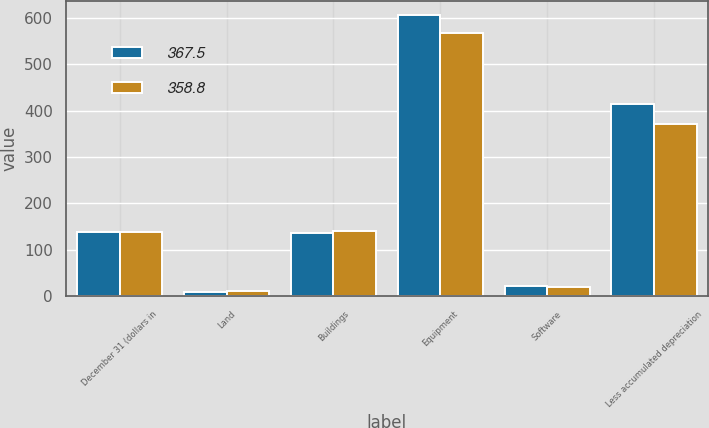<chart> <loc_0><loc_0><loc_500><loc_500><stacked_bar_chart><ecel><fcel>December 31 (dollars in<fcel>Land<fcel>Buildings<fcel>Equipment<fcel>Software<fcel>Less accumulated depreciation<nl><fcel>367.5<fcel>138.4<fcel>9.3<fcel>136.8<fcel>606.6<fcel>21.1<fcel>415<nl><fcel>358.8<fcel>138.4<fcel>10.9<fcel>140<fcel>568<fcel>19.4<fcel>370.8<nl></chart> 